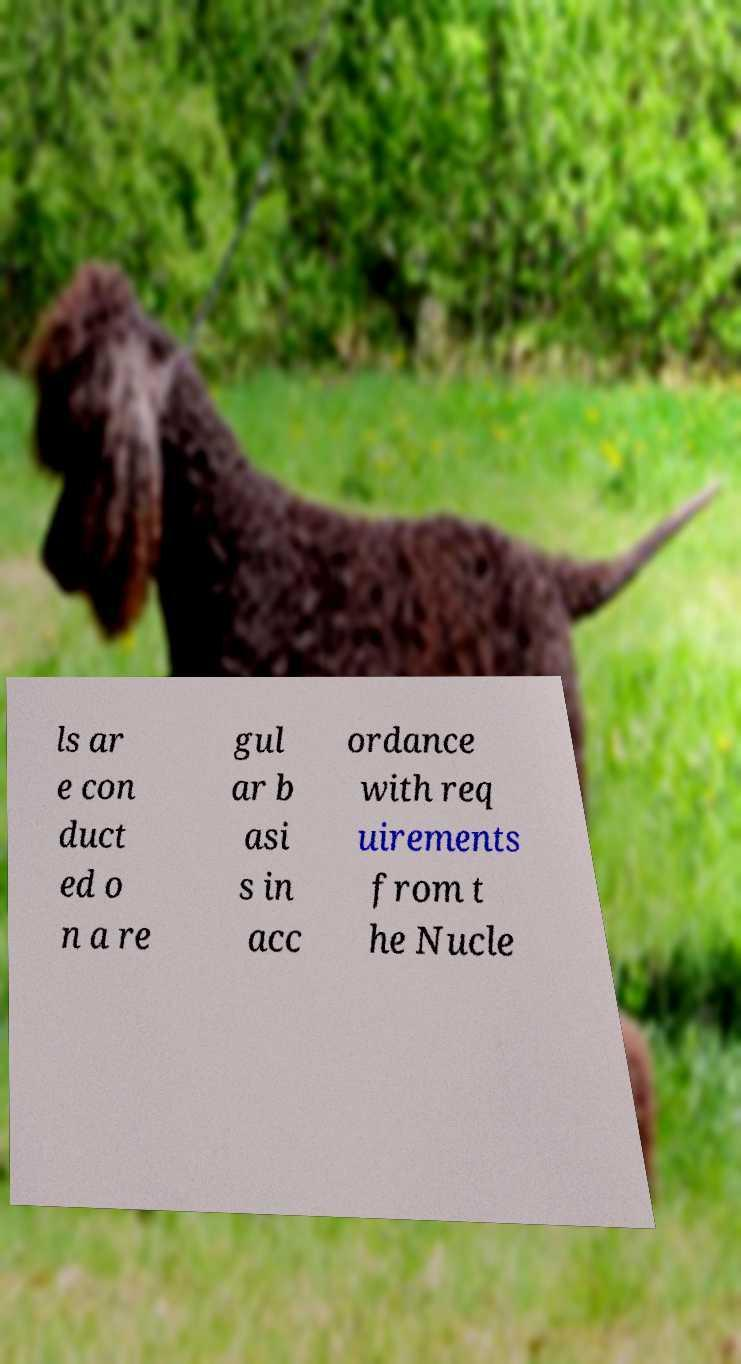There's text embedded in this image that I need extracted. Can you transcribe it verbatim? ls ar e con duct ed o n a re gul ar b asi s in acc ordance with req uirements from t he Nucle 